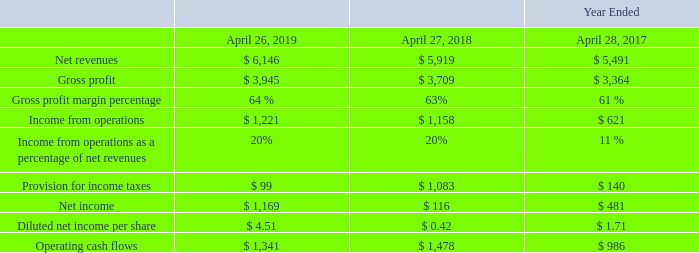Financial Results and Key Performance Metrics Overview
The following table provides an overview of some of our key financial metrics for each of the last three fiscal years (in millions, except per share amounts, percentages and cash conversion cycle):
• Net revenues: Our net revenues increased 4% in fiscal 2019 compared to fiscal 2018. This was primarily due to an increase of 7% in product revenues, partially offset by a 3% decrease in software and hardware maintenance and other services revenues.
• Gross profit margin percentage: Our gross profit margin as a percentage of net revenues increased by one percentage point in fiscal 2019 compared to fiscal 2018, reflecting an increase in gross profit margin on product revenues, and, to a lesser extent, an increase in gross profit margin on hardware maintenance and other services revenues.
• Income from operations as a percentage of net revenues: Our income from operations as a percentage of net revenues remained relatively flat in fiscal 2019 compared to fiscal 2018.
• Provision for income taxes: Our provision for income taxes decreased significantly in fiscal 2019 compared to fiscal 2018 as significant charges were recorded in fiscal 2018 in connection with U.S. tax reform.
• Net income and Diluted income per share: The increase in both net income and diluted net income per share in fiscal 2019 compared to fiscal 2018 reflect the factors discussed above. Diluted net income per share was favorably impacted by a 6% decrease in the annual weighted average number of dilutive shares, primarily due to share repurchases.
• Operating cash flows: Operating cash flows decreased by 9% in fiscal 2019 compared to fiscal 2018, reflecting changes in operating assets and liabilities, partially offset by higher net income.
Which years does the table provide information for some of the company's key financial metrics? 2019, 2018, 2017. What was the gross profit for 2018?
Answer scale should be: million. 3,709. What was the income from operations in 2017?
Answer scale should be: million. 621. How many years did Gross profit margin percentage exceed 60%? 2019##2018##2017
Answer: 3. What was the percentage change in the net income between 2018 and 2019?
Answer scale should be: percent. (1,169-116)/116
Answer: 907.76. What was the change in operating cash flows between 2018 and 2019?
Answer scale should be: million. 1,341-1,478
Answer: -137. 